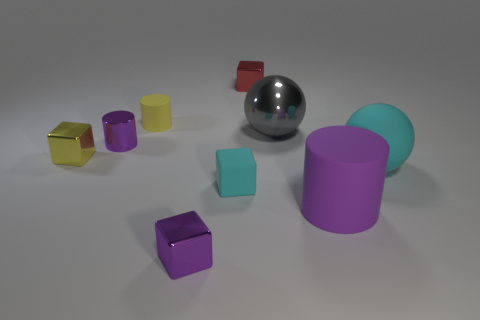Subtract 1 cubes. How many cubes are left? 3 Subtract all spheres. How many objects are left? 7 Subtract all small cylinders. Subtract all small rubber blocks. How many objects are left? 6 Add 7 big objects. How many big objects are left? 10 Add 6 small purple cylinders. How many small purple cylinders exist? 7 Subtract 0 green cubes. How many objects are left? 9 